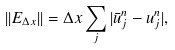Convert formula to latex. <formula><loc_0><loc_0><loc_500><loc_500>| | E _ { \Delta x } | | = \Delta x \sum _ { j } | \bar { u } _ { j } ^ { n } - u _ { j } ^ { n } | ,</formula> 